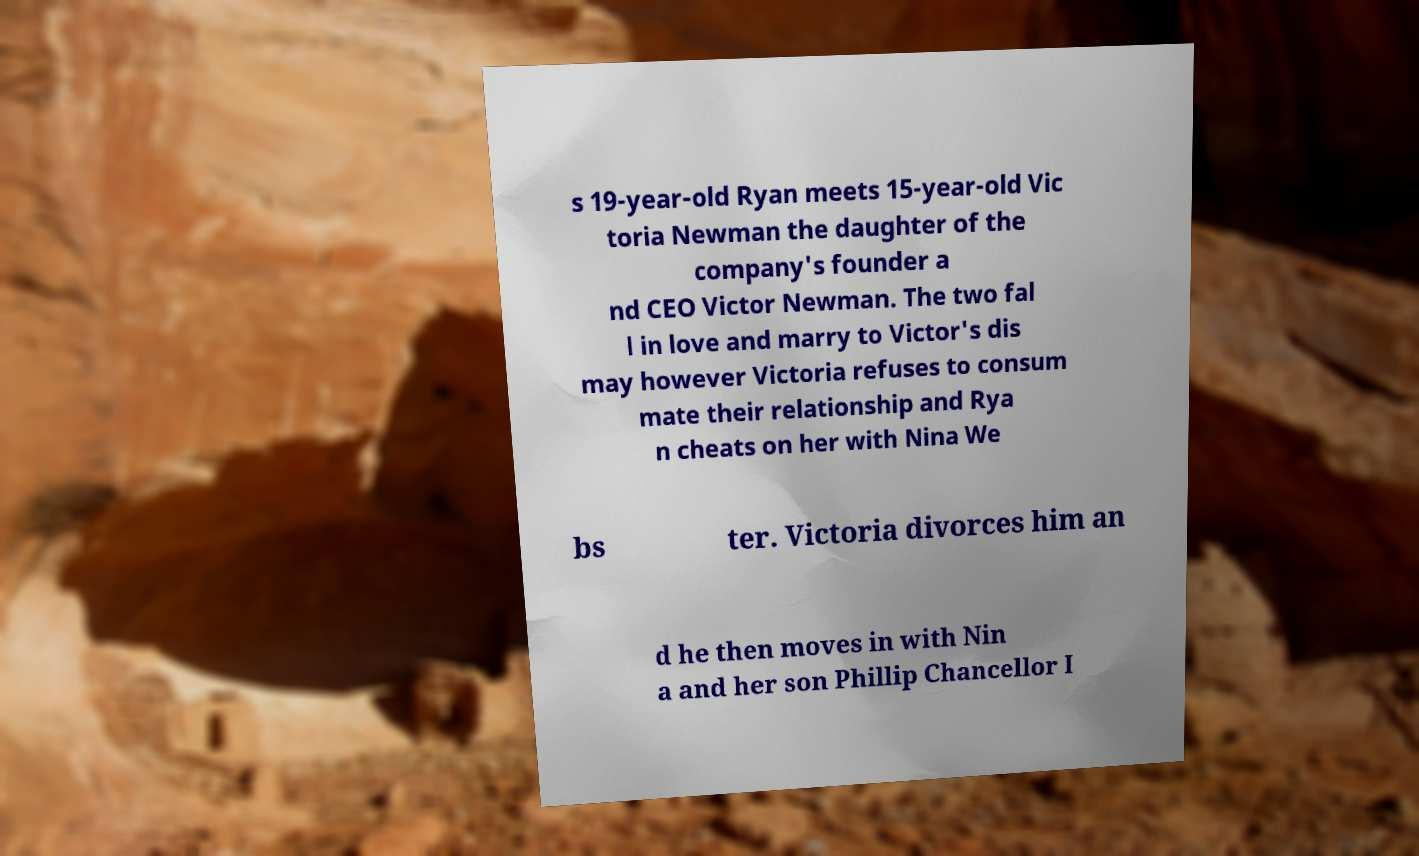There's text embedded in this image that I need extracted. Can you transcribe it verbatim? s 19-year-old Ryan meets 15-year-old Vic toria Newman the daughter of the company's founder a nd CEO Victor Newman. The two fal l in love and marry to Victor's dis may however Victoria refuses to consum mate their relationship and Rya n cheats on her with Nina We bs ter. Victoria divorces him an d he then moves in with Nin a and her son Phillip Chancellor I 